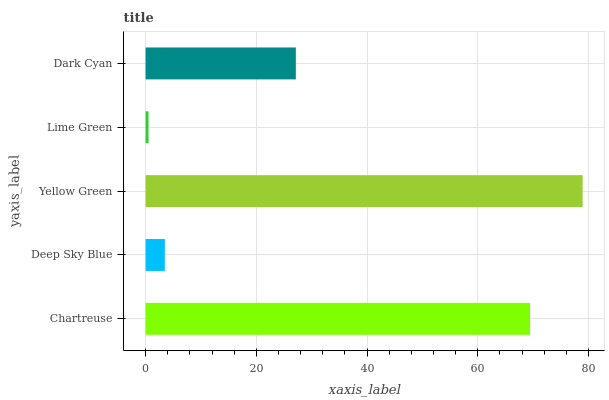Is Lime Green the minimum?
Answer yes or no. Yes. Is Yellow Green the maximum?
Answer yes or no. Yes. Is Deep Sky Blue the minimum?
Answer yes or no. No. Is Deep Sky Blue the maximum?
Answer yes or no. No. Is Chartreuse greater than Deep Sky Blue?
Answer yes or no. Yes. Is Deep Sky Blue less than Chartreuse?
Answer yes or no. Yes. Is Deep Sky Blue greater than Chartreuse?
Answer yes or no. No. Is Chartreuse less than Deep Sky Blue?
Answer yes or no. No. Is Dark Cyan the high median?
Answer yes or no. Yes. Is Dark Cyan the low median?
Answer yes or no. Yes. Is Deep Sky Blue the high median?
Answer yes or no. No. Is Chartreuse the low median?
Answer yes or no. No. 